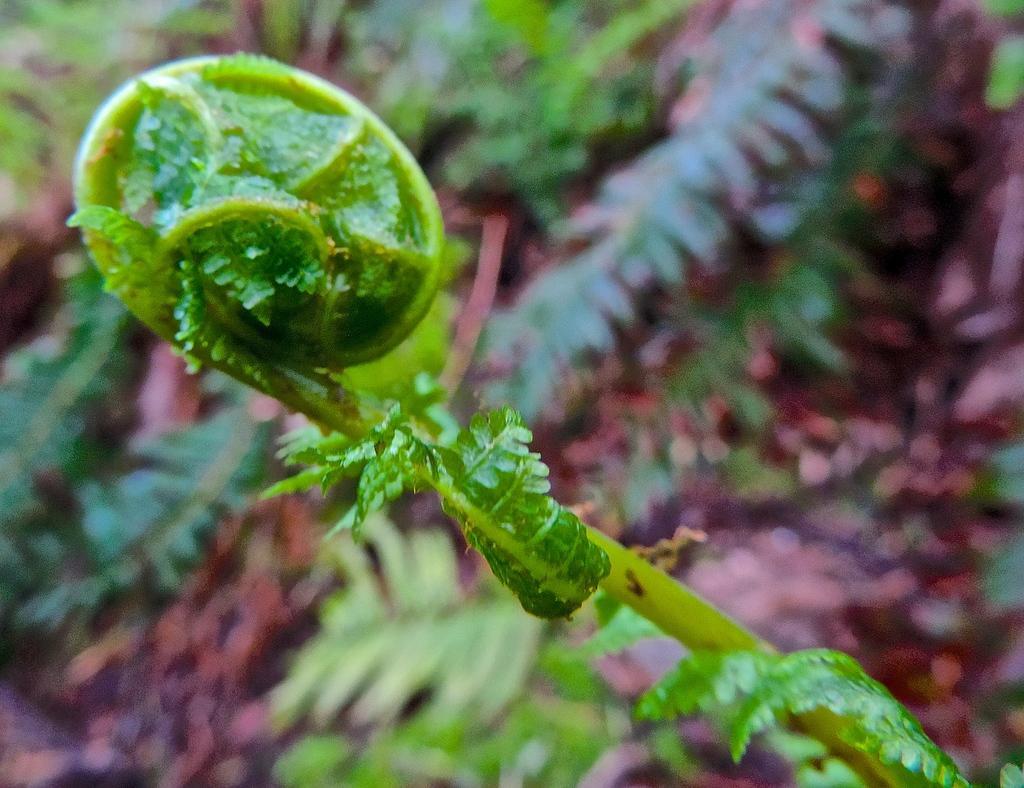Could you give a brief overview of what you see in this image? In this picture I can see the plants and grass. At the top I can see the leaves. 